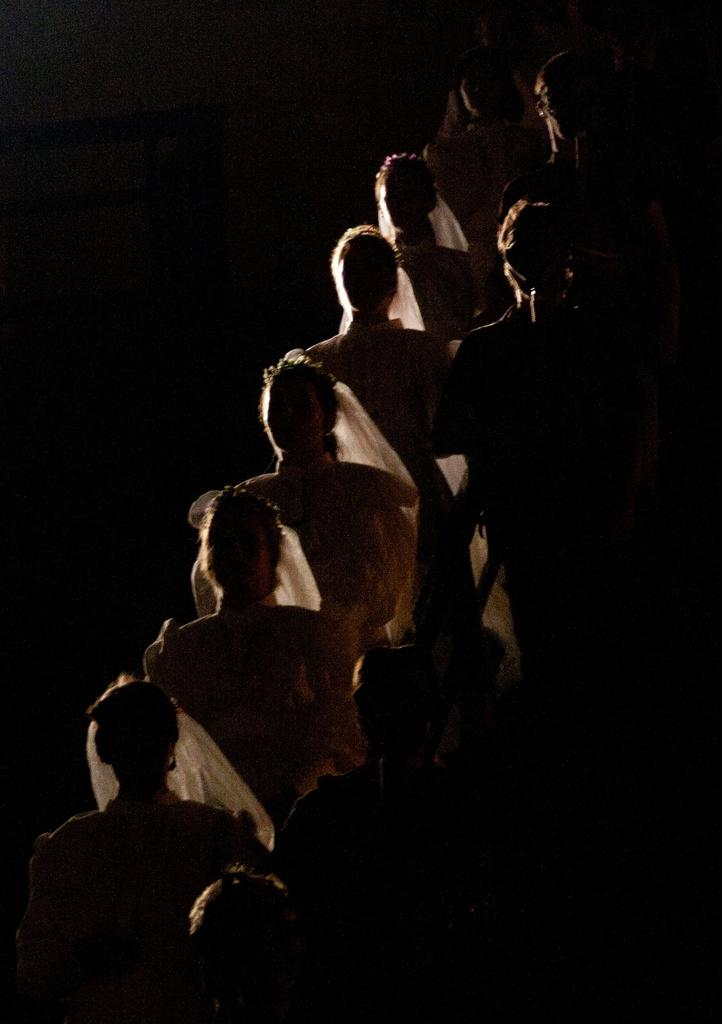How many people are in the image? There are people in the image, but the exact number is not specified. Where are the people located in the image? The people are standing in the center of the image. What are the people wearing in the image? The people are wearing costumes in the image. What type of pin can be seen holding the costumes together in the image? There is no pin visible in the image; the people are wearing costumes, but there is no mention of any pins holding them together. Can you tell me how many tramps are present in the image? There is no reference to any tramps in the image; it features people wearing costumes. 